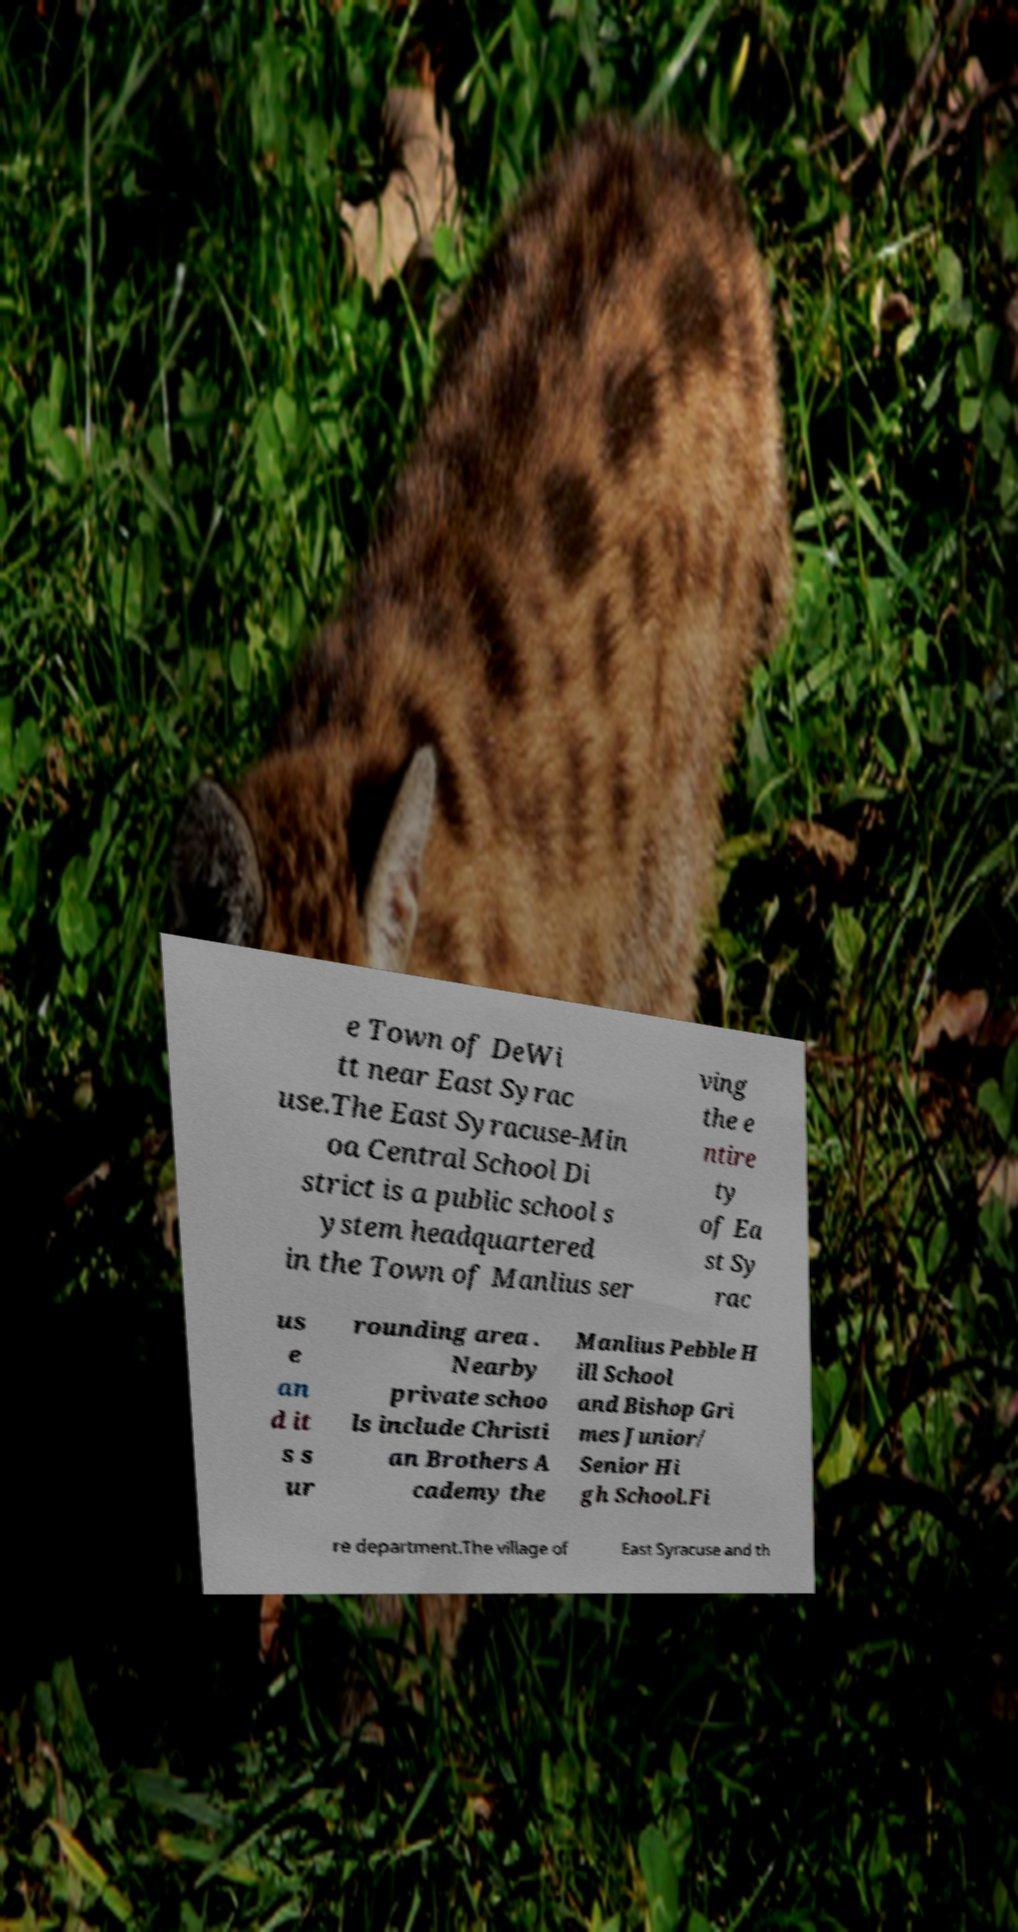For documentation purposes, I need the text within this image transcribed. Could you provide that? e Town of DeWi tt near East Syrac use.The East Syracuse-Min oa Central School Di strict is a public school s ystem headquartered in the Town of Manlius ser ving the e ntire ty of Ea st Sy rac us e an d it s s ur rounding area . Nearby private schoo ls include Christi an Brothers A cademy the Manlius Pebble H ill School and Bishop Gri mes Junior/ Senior Hi gh School.Fi re department.The village of East Syracuse and th 